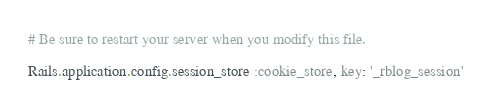<code> <loc_0><loc_0><loc_500><loc_500><_Ruby_># Be sure to restart your server when you modify this file.

Rails.application.config.session_store :cookie_store, key: '_rblog_session'
</code> 